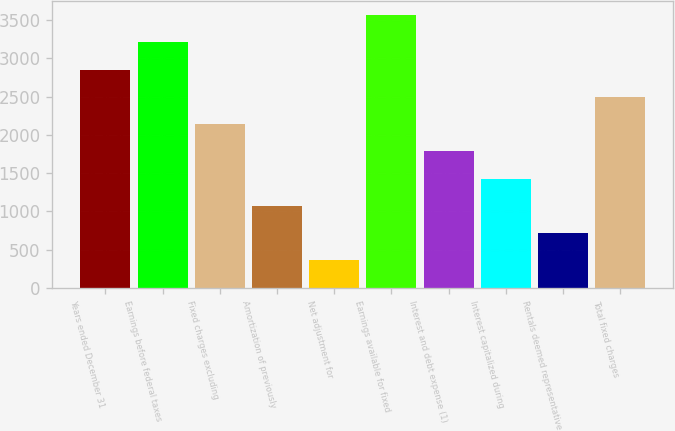<chart> <loc_0><loc_0><loc_500><loc_500><bar_chart><fcel>Years ended December 31<fcel>Earnings before federal taxes<fcel>Fixed charges excluding<fcel>Amortization of previously<fcel>Net adjustment for<fcel>Earnings available for fixed<fcel>Interest and debt expense (1)<fcel>Interest capitalized during<fcel>Rentals deemed representative<fcel>Total fixed charges<nl><fcel>2851.32<fcel>3207.16<fcel>2139.64<fcel>1072.12<fcel>360.44<fcel>3563<fcel>1783.8<fcel>1427.96<fcel>716.28<fcel>2495.48<nl></chart> 